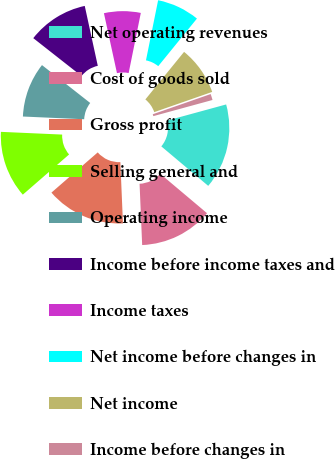Convert chart. <chart><loc_0><loc_0><loc_500><loc_500><pie_chart><fcel>Net operating revenues<fcel>Cost of goods sold<fcel>Gross profit<fcel>Selling general and<fcel>Operating income<fcel>Income before income taxes and<fcel>Income taxes<fcel>Net income before changes in<fcel>Net income<fcel>Income before changes in<nl><fcel>15.38%<fcel>13.19%<fcel>14.29%<fcel>12.09%<fcel>9.89%<fcel>10.99%<fcel>6.59%<fcel>7.69%<fcel>8.79%<fcel>1.1%<nl></chart> 